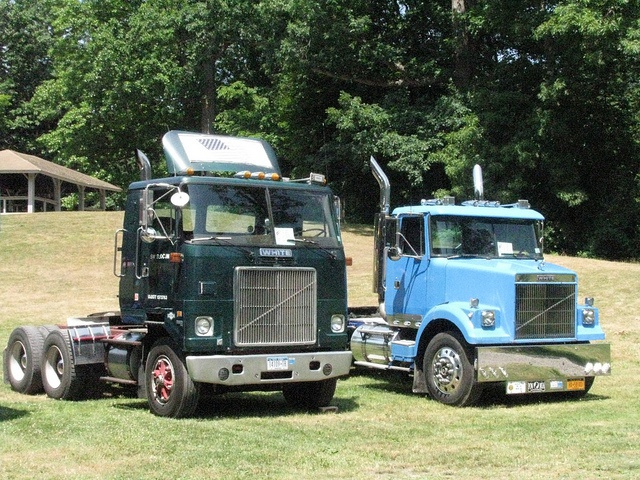Describe the objects in this image and their specific colors. I can see truck in aquamarine, black, gray, darkgray, and white tones and truck in aquamarine, gray, black, and lightblue tones in this image. 